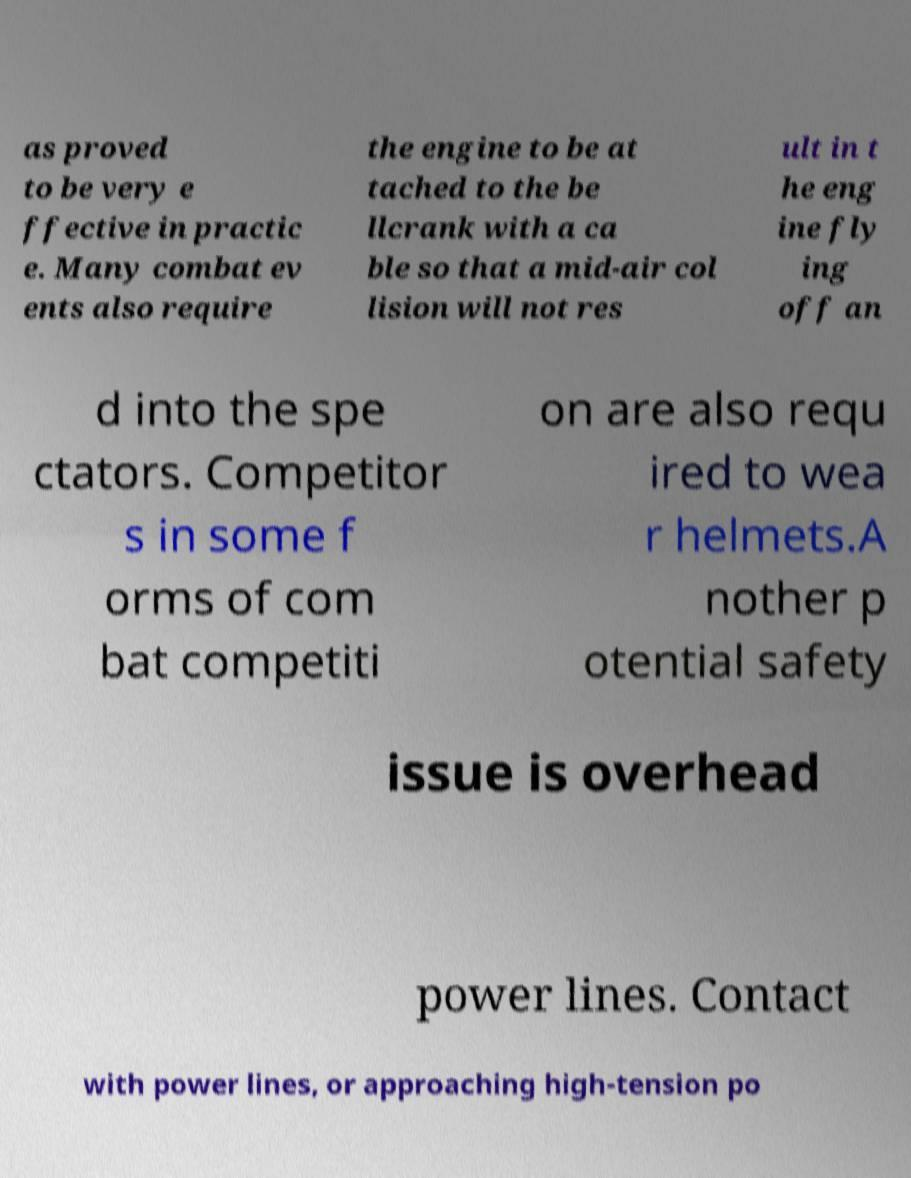Can you read and provide the text displayed in the image?This photo seems to have some interesting text. Can you extract and type it out for me? as proved to be very e ffective in practic e. Many combat ev ents also require the engine to be at tached to the be llcrank with a ca ble so that a mid-air col lision will not res ult in t he eng ine fly ing off an d into the spe ctators. Competitor s in some f orms of com bat competiti on are also requ ired to wea r helmets.A nother p otential safety issue is overhead power lines. Contact with power lines, or approaching high-tension po 